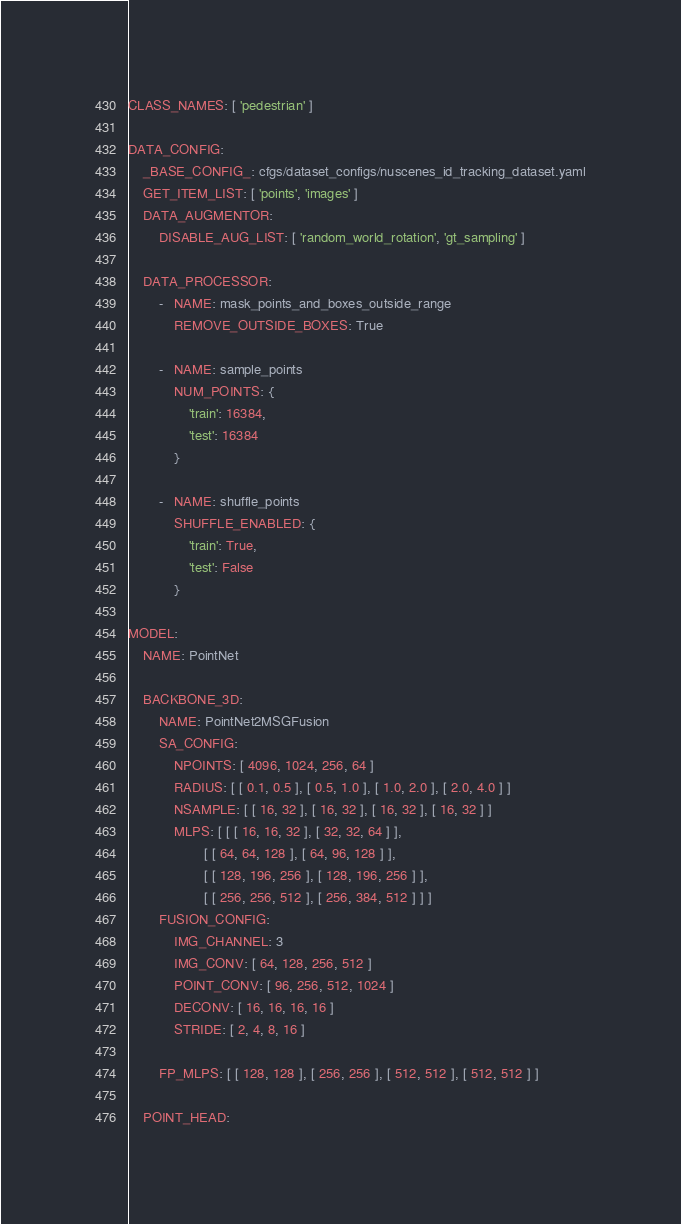<code> <loc_0><loc_0><loc_500><loc_500><_YAML_>CLASS_NAMES: [ 'pedestrian' ]

DATA_CONFIG:
    _BASE_CONFIG_: cfgs/dataset_configs/nuscenes_id_tracking_dataset.yaml
    GET_ITEM_LIST: [ 'points', 'images' ]
    DATA_AUGMENTOR:
        DISABLE_AUG_LIST: [ 'random_world_rotation', 'gt_sampling' ]

    DATA_PROCESSOR:
        -   NAME: mask_points_and_boxes_outside_range
            REMOVE_OUTSIDE_BOXES: True

        -   NAME: sample_points
            NUM_POINTS: {
                'train': 16384,
                'test': 16384
            }

        -   NAME: shuffle_points
            SHUFFLE_ENABLED: {
                'train': True,
                'test': False
            }

MODEL:
    NAME: PointNet

    BACKBONE_3D:
        NAME: PointNet2MSGFusion
        SA_CONFIG:
            NPOINTS: [ 4096, 1024, 256, 64 ]
            RADIUS: [ [ 0.1, 0.5 ], [ 0.5, 1.0 ], [ 1.0, 2.0 ], [ 2.0, 4.0 ] ]
            NSAMPLE: [ [ 16, 32 ], [ 16, 32 ], [ 16, 32 ], [ 16, 32 ] ]
            MLPS: [ [ [ 16, 16, 32 ], [ 32, 32, 64 ] ],
                    [ [ 64, 64, 128 ], [ 64, 96, 128 ] ],
                    [ [ 128, 196, 256 ], [ 128, 196, 256 ] ],
                    [ [ 256, 256, 512 ], [ 256, 384, 512 ] ] ]
        FUSION_CONFIG:
            IMG_CHANNEL: 3
            IMG_CONV: [ 64, 128, 256, 512 ]
            POINT_CONV: [ 96, 256, 512, 1024 ]
            DECONV: [ 16, 16, 16, 16 ]
            STRIDE: [ 2, 4, 8, 16 ]

        FP_MLPS: [ [ 128, 128 ], [ 256, 256 ], [ 512, 512 ], [ 512, 512 ] ]

    POINT_HEAD:</code> 